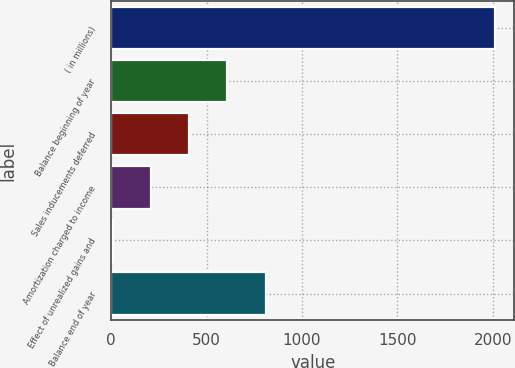Convert chart. <chart><loc_0><loc_0><loc_500><loc_500><bar_chart><fcel>( in millions)<fcel>Balance beginning of year<fcel>Sales inducements deferred<fcel>Amortization charged to income<fcel>Effect of unrealized gains and<fcel>Balance end of year<nl><fcel>2012<fcel>609.2<fcel>408.8<fcel>208.4<fcel>8<fcel>809.6<nl></chart> 